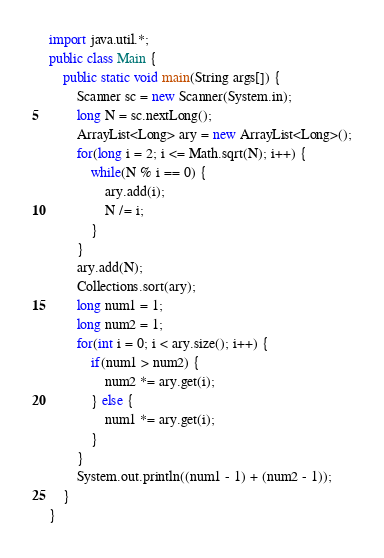<code> <loc_0><loc_0><loc_500><loc_500><_Java_>import java.util.*;
public class Main {
	public static void main(String args[]) {
		Scanner sc = new Scanner(System.in);
		long N = sc.nextLong();
		ArrayList<Long> ary = new ArrayList<Long>();
		for(long i = 2; i <= Math.sqrt(N); i++) {
			while(N % i == 0) {
				ary.add(i);
				N /= i;
			}
		}
		ary.add(N);
		Collections.sort(ary);
		long num1 = 1;
		long num2 = 1;
		for(int i = 0; i < ary.size(); i++) {
			if(num1 > num2) {
				num2 *= ary.get(i);
			} else {
				num1 *= ary.get(i);
			}
		}
		System.out.println((num1 - 1) + (num2 - 1));
	}
}
</code> 